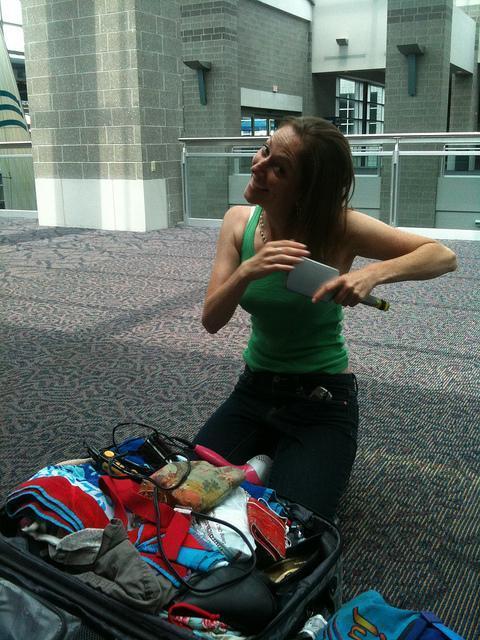How many giraffes are there?
Give a very brief answer. 0. 